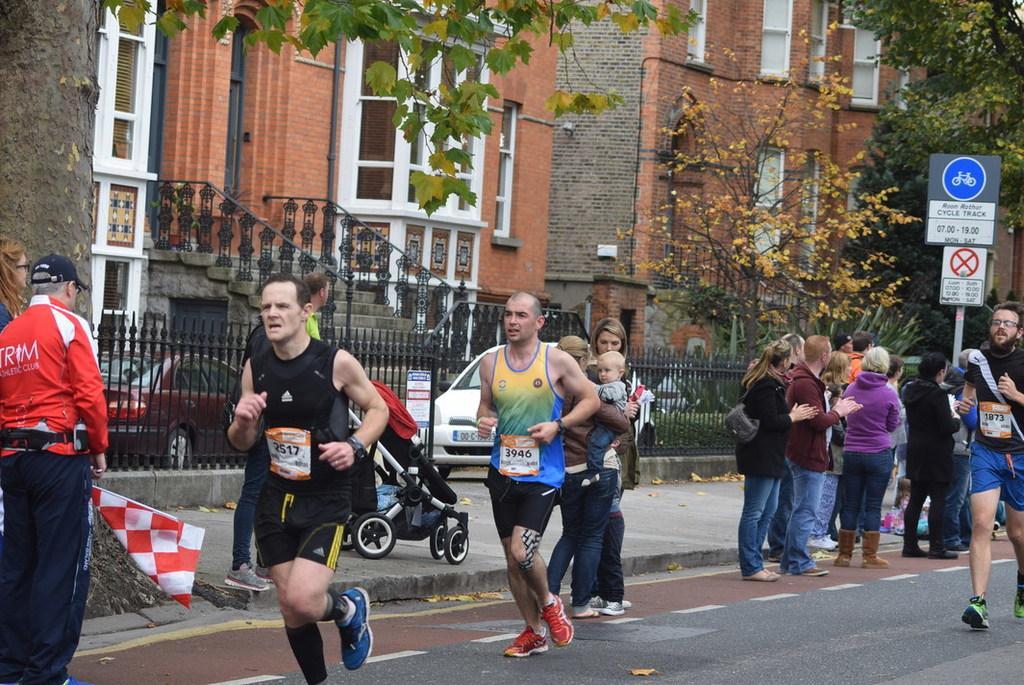How would you summarize this image in a sentence or two? In the middle of the image few people are running. Behind them few people are standing and watching and few people are holding a stroller and baby. Behind them we can see fencing. Behind the fencing we can see some vehicles, trees, buildings, poles and sign boards. 